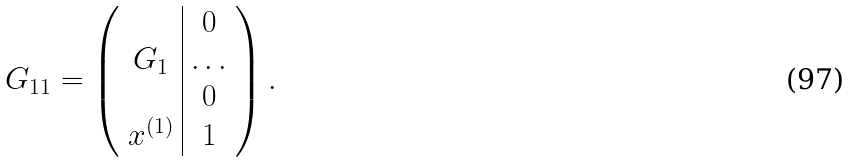Convert formula to latex. <formula><loc_0><loc_0><loc_500><loc_500>G _ { 1 1 } = \left ( \begin{array} { c | c } & 0 \\ G _ { 1 } & \dots \\ & 0 \\ x ^ { ( 1 ) } & 1 \end{array} \right ) .</formula> 